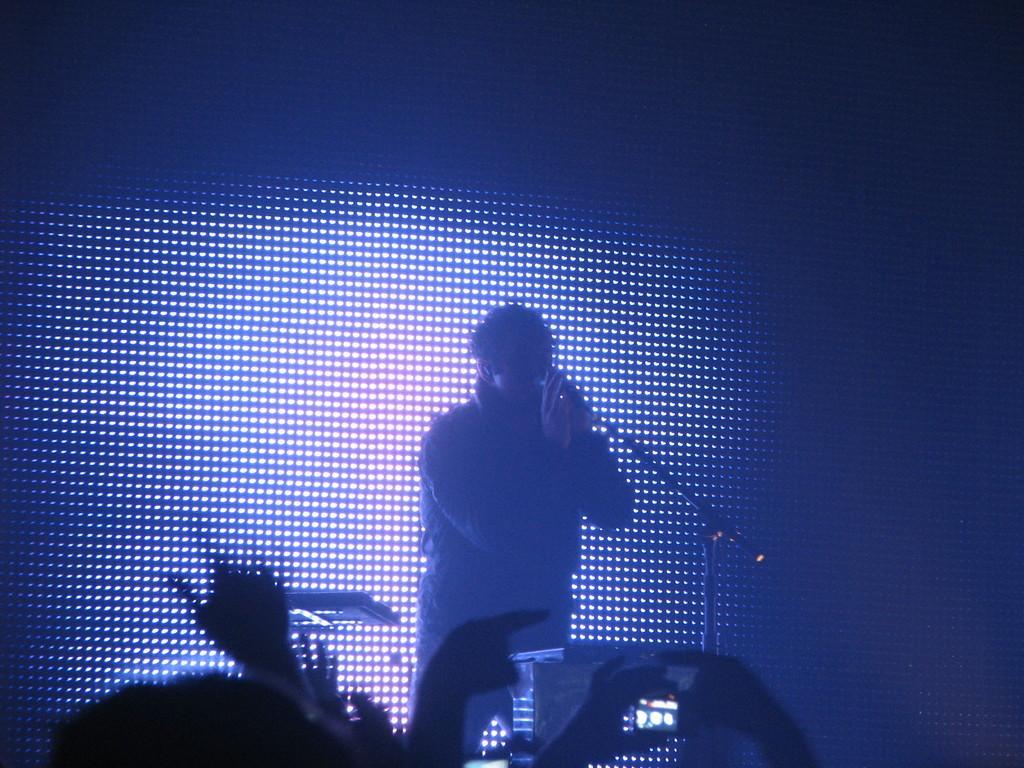Could you give a brief overview of what you see in this image? In this picture there is a person standing and singing in front of a mic and there are few objects and audience in front of him and there are few lights behind him. 